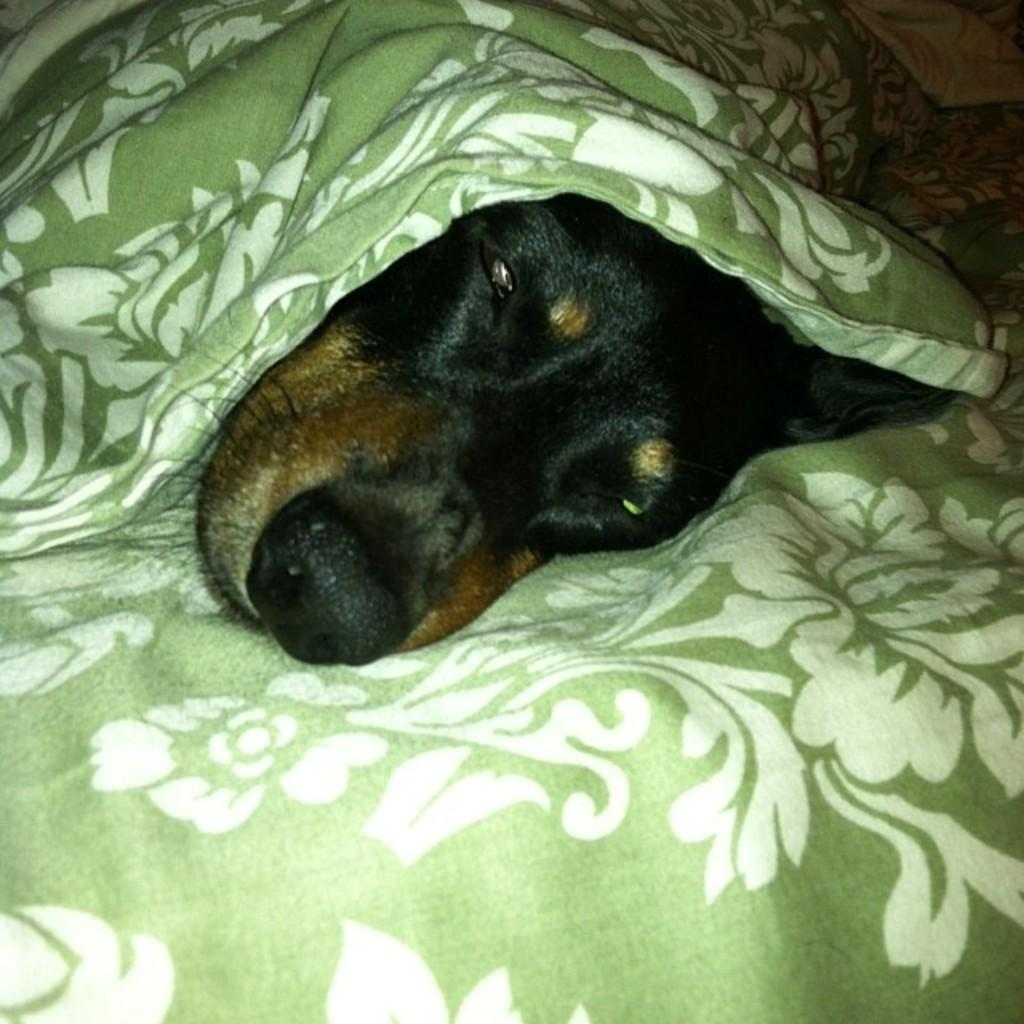What type of animal is in the image? There is a dog in the image. What is the dog doing in the image? The dog is laying on a blanket. Where is the blanket located in the image? The blanket is on a bed. What type of sand can be seen in the image? There is no sand present in the image; it features a dog laying on a blanket on a bed. 